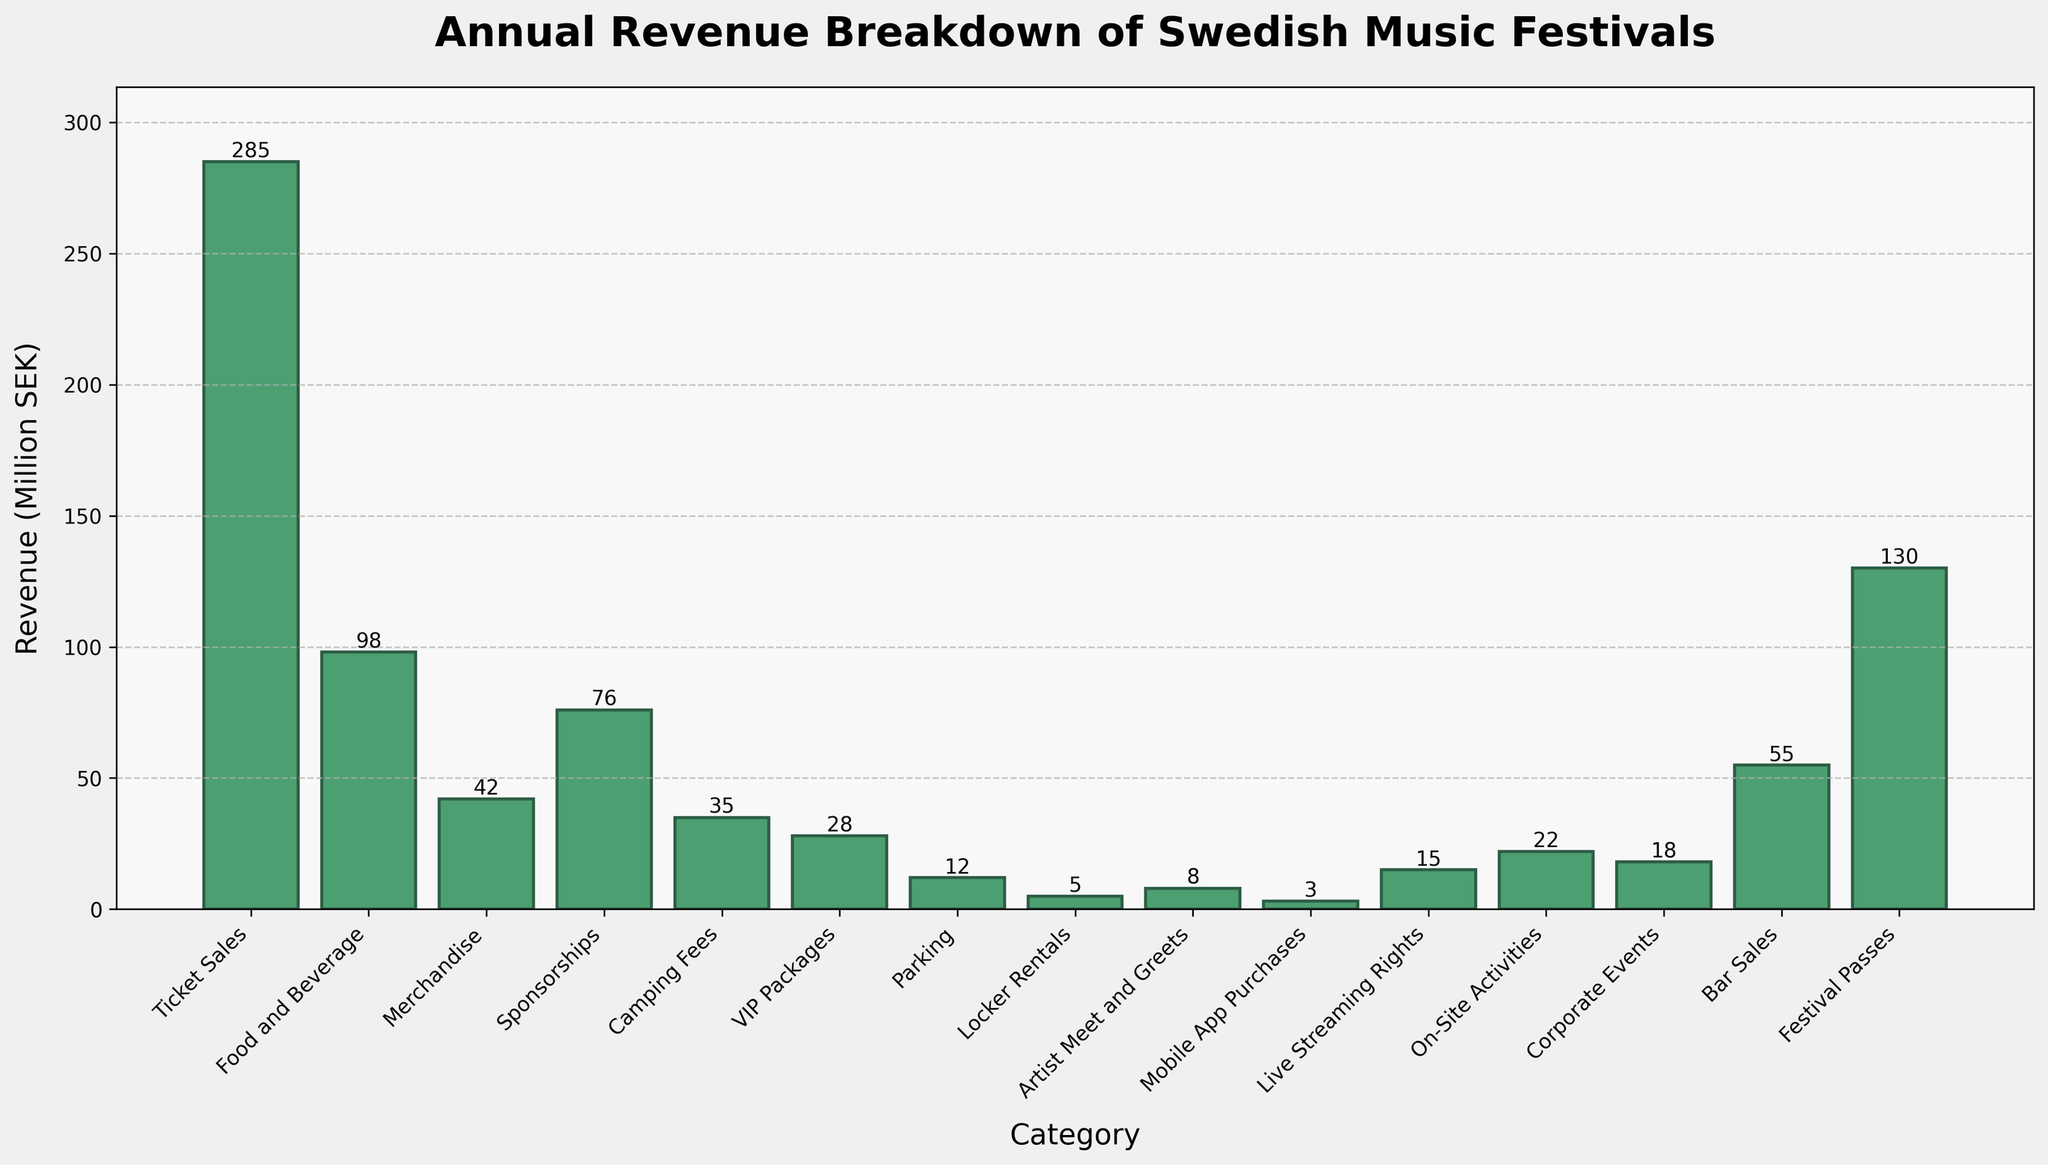What is the total revenue generated from Ticket Sales and Festival Passes combined? Add the revenue from Ticket Sales (285 million SEK) and Festival Passes (130 million SEK) to get a combined total. 285 + 130 = 415 million SEK.
Answer: 415 million SEK Which category generated the least revenue? Compare the revenue values of all categories. The category with the smallest value is Mobile App Purchases at 3 million SEK.
Answer: Mobile App Purchases How does the revenue from Bar Sales compare to the revenue from Food and Beverage? Compare the revenue values of Bar Sales (55 million SEK) and Food and Beverage (98 million SEK). Bar Sales is less than Food and Beverage.
Answer: Bar Sales generates less revenue What is the difference in revenue between Sponsorships and Merchandise? Subtract the revenue of Merchandise (42 million SEK) from Sponsorships (76 million SEK). 76 - 42 = 34 million SEK.
Answer: 34 million SEK Are there any categories with equal revenue? Compare all the revenue values to check for equality. No two categories have the same revenue value.
Answer: No How many categories have revenue of 20 million SEK or more? Count the categories where revenue is 20 million SEK or more. This includes Ticket Sales, Food and Beverage, Merchandise, Sponsorships, Festival Passes, Bar Sales, On-Site Activities, and Corporate Events. There are 8 such categories.
Answer: 8 categories Which category has the highest revenue? Identify the category with the highest revenue value. Ticket Sales has the highest revenue at 285 million SEK.
Answer: Ticket Sales What is the total revenue from all categories? Sum the revenue values from all categories: 285 + 98 + 42 + 76 + 35 + 28 + 12 + 5 + 8 + 3 + 15 + 22 + 18 + 55 + 130 = 832 million SEK.
Answer: 832 million SEK How does the height of the Parking bar visually compare to that of the Live Streaming Rights bar? Observe the height of the bars on the chart. The Parking bar (12 million SEK) is shorter than the Live Streaming Rights bar (15 million SEK).
Answer: Parking is shorter Is the revenue from VIP Packages higher than Camping Fees? Compare the revenue of VIP Packages (28 million SEK) with Camping Fees (35 million SEK). VIP Packages is less than Camping Fees.
Answer: No 